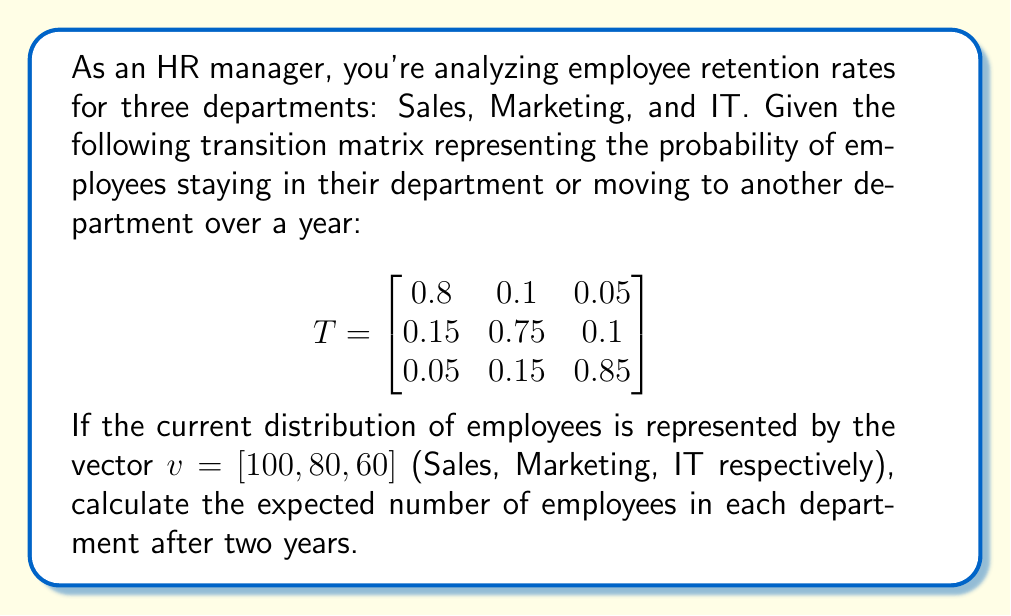Provide a solution to this math problem. To solve this problem, we need to multiply the initial distribution vector by the transition matrix twice, as we want to know the distribution after two years.

Step 1: Calculate the distribution after one year
Let's call the distribution after one year $v_1$:

$v_1 = v \cdot T$

$v_1 = [100, 80, 60] \cdot \begin{bmatrix}
0.8 & 0.1 & 0.05 \\
0.15 & 0.75 & 0.1 \\
0.05 & 0.15 & 0.85
\end{bmatrix}$

$v_1 = [89, 79, 72]$

Step 2: Calculate the distribution after two years
Now we multiply $v_1$ by T again to get the distribution after two years, $v_2$:

$v_2 = v_1 \cdot T$

$v_2 = [89, 79, 72] \cdot \begin{bmatrix}
0.8 & 0.1 & 0.05 \\
0.15 & 0.75 & 0.1 \\
0.05 & 0.15 & 0.85
\end{bmatrix}$

$v_2 = [81.95, 77.9, 80.15]$

Step 3: Round the results to the nearest whole number
Since we're dealing with employees, we need to round the results to the nearest integer:

Sales: 82
Marketing: 78
IT: 80
Answer: [82, 78, 80] 